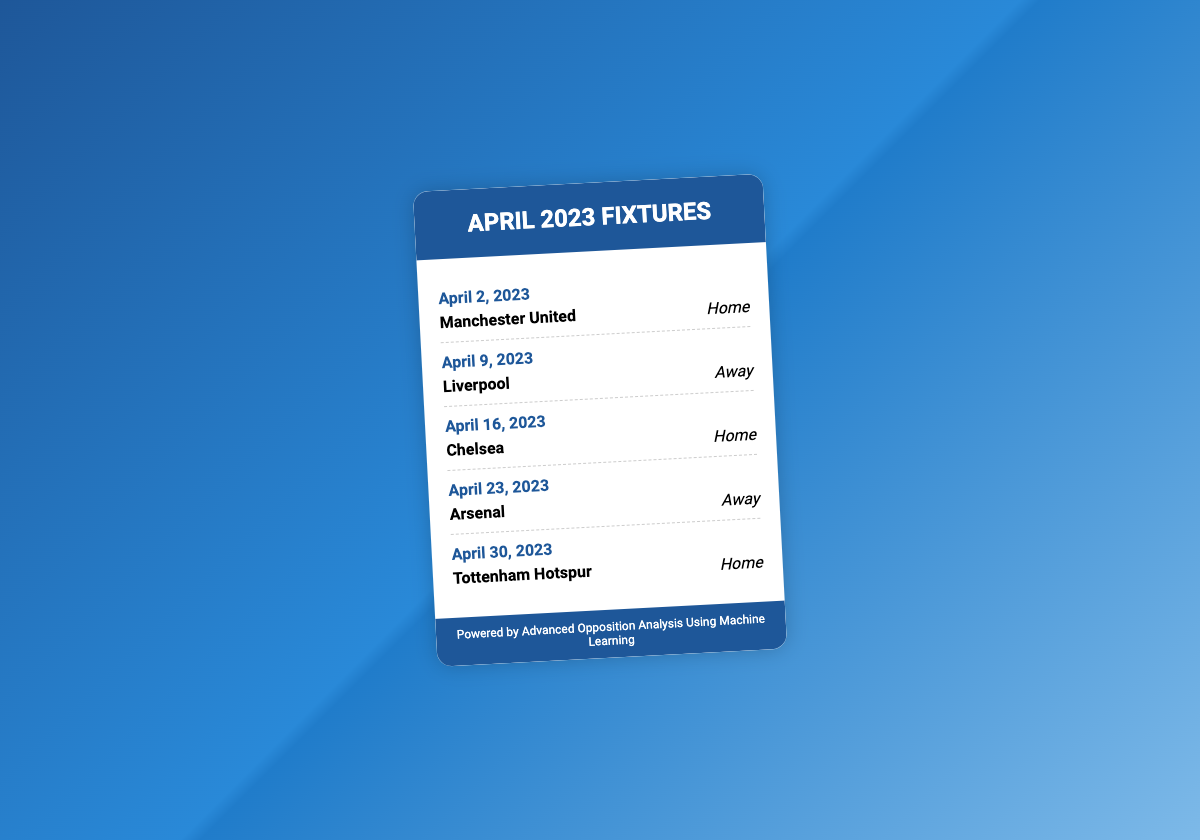What is the date of the match against Manchester United? The date mentioned in the document for the match against Manchester United is specifically stated.
Answer: April 2, 2023 Which team is the opponent on April 9, 2023? The document clearly identifies the opponent for the match on this date.
Answer: Liverpool How many fixtures are listed for April 2023? The total number of fixtures presented in the document is counted visually.
Answer: 5 Where is the match against Chelsea taking place? The document mentions the venue for the match against Chelsea.
Answer: Home What is the last fixture listed for April 2023? The document provides a list, and the last fixture is noted down accordingly.
Answer: Tottenham Hotspur Which team will the club play away on April 23, 2023? The document specifically states the away match opponent for this date.
Answer: Arsenal What is the significance of the footer statement? The footer indicates the technology used for advanced opposition analysis relevant to team strategy.
Answer: Advanced Opposition Analysis Using Machine Learning 